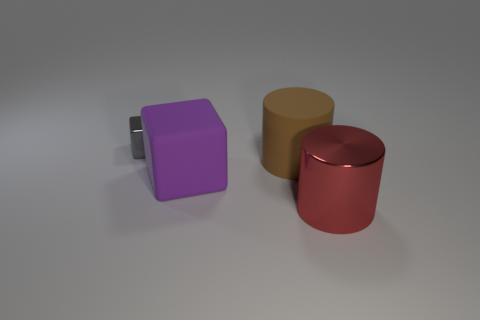Add 2 small green blocks. How many objects exist? 6 Add 4 small yellow metallic objects. How many small yellow metallic objects exist? 4 Subtract 0 cyan blocks. How many objects are left? 4 Subtract all large blue shiny objects. Subtract all small gray metallic objects. How many objects are left? 3 Add 1 big brown cylinders. How many big brown cylinders are left? 2 